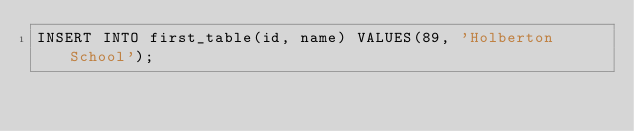Convert code to text. <code><loc_0><loc_0><loc_500><loc_500><_SQL_>INSERT INTO first_table(id, name) VALUES(89, 'Holberton School');
</code> 